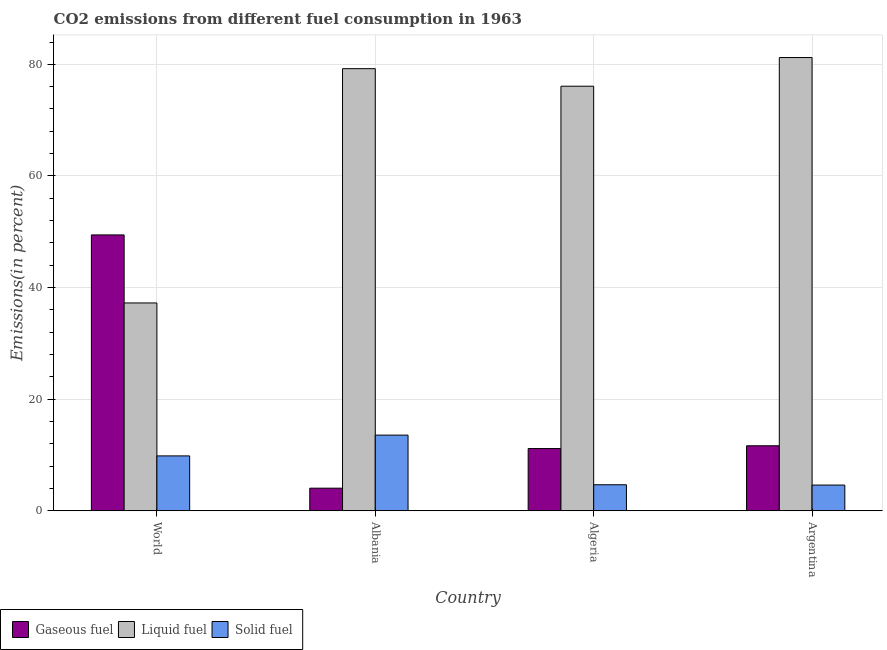How many different coloured bars are there?
Provide a succinct answer. 3. Are the number of bars on each tick of the X-axis equal?
Your response must be concise. Yes. How many bars are there on the 2nd tick from the left?
Offer a very short reply. 3. What is the label of the 2nd group of bars from the left?
Make the answer very short. Albania. In how many cases, is the number of bars for a given country not equal to the number of legend labels?
Your answer should be compact. 0. What is the percentage of liquid fuel emission in Algeria?
Give a very brief answer. 76.08. Across all countries, what is the maximum percentage of solid fuel emission?
Your answer should be compact. 13.56. Across all countries, what is the minimum percentage of liquid fuel emission?
Make the answer very short. 37.24. In which country was the percentage of solid fuel emission maximum?
Give a very brief answer. Albania. What is the total percentage of gaseous fuel emission in the graph?
Make the answer very short. 76.28. What is the difference between the percentage of liquid fuel emission in Algeria and that in World?
Your response must be concise. 38.84. What is the difference between the percentage of liquid fuel emission in Algeria and the percentage of solid fuel emission in World?
Your response must be concise. 66.25. What is the average percentage of solid fuel emission per country?
Offer a very short reply. 8.16. What is the difference between the percentage of liquid fuel emission and percentage of solid fuel emission in Algeria?
Your answer should be compact. 71.42. What is the ratio of the percentage of solid fuel emission in Albania to that in World?
Give a very brief answer. 1.38. Is the percentage of gaseous fuel emission in Albania less than that in World?
Ensure brevity in your answer.  Yes. Is the difference between the percentage of liquid fuel emission in Albania and Algeria greater than the difference between the percentage of gaseous fuel emission in Albania and Algeria?
Your answer should be compact. Yes. What is the difference between the highest and the second highest percentage of liquid fuel emission?
Give a very brief answer. 1.99. What is the difference between the highest and the lowest percentage of liquid fuel emission?
Your answer should be very brief. 43.98. Is the sum of the percentage of liquid fuel emission in Albania and Argentina greater than the maximum percentage of gaseous fuel emission across all countries?
Ensure brevity in your answer.  Yes. What does the 1st bar from the left in Algeria represents?
Provide a succinct answer. Gaseous fuel. What does the 3rd bar from the right in Algeria represents?
Ensure brevity in your answer.  Gaseous fuel. What is the difference between two consecutive major ticks on the Y-axis?
Offer a terse response. 20. Are the values on the major ticks of Y-axis written in scientific E-notation?
Ensure brevity in your answer.  No. Does the graph contain any zero values?
Give a very brief answer. No. Does the graph contain grids?
Offer a terse response. Yes. How are the legend labels stacked?
Provide a short and direct response. Horizontal. What is the title of the graph?
Make the answer very short. CO2 emissions from different fuel consumption in 1963. What is the label or title of the Y-axis?
Give a very brief answer. Emissions(in percent). What is the Emissions(in percent) in Gaseous fuel in World?
Provide a succinct answer. 49.43. What is the Emissions(in percent) in Liquid fuel in World?
Provide a short and direct response. 37.24. What is the Emissions(in percent) in Solid fuel in World?
Offer a very short reply. 9.83. What is the Emissions(in percent) in Gaseous fuel in Albania?
Offer a terse response. 4.05. What is the Emissions(in percent) of Liquid fuel in Albania?
Keep it short and to the point. 79.23. What is the Emissions(in percent) in Solid fuel in Albania?
Offer a terse response. 13.56. What is the Emissions(in percent) of Gaseous fuel in Algeria?
Ensure brevity in your answer.  11.15. What is the Emissions(in percent) of Liquid fuel in Algeria?
Offer a very short reply. 76.08. What is the Emissions(in percent) in Solid fuel in Algeria?
Your response must be concise. 4.66. What is the Emissions(in percent) of Gaseous fuel in Argentina?
Give a very brief answer. 11.65. What is the Emissions(in percent) of Liquid fuel in Argentina?
Keep it short and to the point. 81.22. What is the Emissions(in percent) in Solid fuel in Argentina?
Keep it short and to the point. 4.61. Across all countries, what is the maximum Emissions(in percent) of Gaseous fuel?
Keep it short and to the point. 49.43. Across all countries, what is the maximum Emissions(in percent) in Liquid fuel?
Offer a terse response. 81.22. Across all countries, what is the maximum Emissions(in percent) of Solid fuel?
Provide a short and direct response. 13.56. Across all countries, what is the minimum Emissions(in percent) of Gaseous fuel?
Your answer should be very brief. 4.05. Across all countries, what is the minimum Emissions(in percent) of Liquid fuel?
Keep it short and to the point. 37.24. Across all countries, what is the minimum Emissions(in percent) of Solid fuel?
Ensure brevity in your answer.  4.61. What is the total Emissions(in percent) of Gaseous fuel in the graph?
Ensure brevity in your answer.  76.28. What is the total Emissions(in percent) in Liquid fuel in the graph?
Your answer should be very brief. 273.77. What is the total Emissions(in percent) of Solid fuel in the graph?
Offer a very short reply. 32.66. What is the difference between the Emissions(in percent) of Gaseous fuel in World and that in Albania?
Provide a succinct answer. 45.38. What is the difference between the Emissions(in percent) of Liquid fuel in World and that in Albania?
Offer a terse response. -41.99. What is the difference between the Emissions(in percent) in Solid fuel in World and that in Albania?
Offer a very short reply. -3.72. What is the difference between the Emissions(in percent) of Gaseous fuel in World and that in Algeria?
Keep it short and to the point. 38.28. What is the difference between the Emissions(in percent) of Liquid fuel in World and that in Algeria?
Offer a very short reply. -38.84. What is the difference between the Emissions(in percent) of Solid fuel in World and that in Algeria?
Ensure brevity in your answer.  5.17. What is the difference between the Emissions(in percent) of Gaseous fuel in World and that in Argentina?
Provide a short and direct response. 37.78. What is the difference between the Emissions(in percent) of Liquid fuel in World and that in Argentina?
Provide a succinct answer. -43.98. What is the difference between the Emissions(in percent) of Solid fuel in World and that in Argentina?
Your answer should be very brief. 5.23. What is the difference between the Emissions(in percent) in Gaseous fuel in Albania and that in Algeria?
Your response must be concise. -7.1. What is the difference between the Emissions(in percent) in Liquid fuel in Albania and that in Algeria?
Your answer should be compact. 3.14. What is the difference between the Emissions(in percent) in Solid fuel in Albania and that in Algeria?
Offer a very short reply. 8.89. What is the difference between the Emissions(in percent) of Gaseous fuel in Albania and that in Argentina?
Offer a terse response. -7.6. What is the difference between the Emissions(in percent) in Liquid fuel in Albania and that in Argentina?
Make the answer very short. -1.99. What is the difference between the Emissions(in percent) in Solid fuel in Albania and that in Argentina?
Ensure brevity in your answer.  8.95. What is the difference between the Emissions(in percent) of Gaseous fuel in Algeria and that in Argentina?
Keep it short and to the point. -0.5. What is the difference between the Emissions(in percent) in Liquid fuel in Algeria and that in Argentina?
Keep it short and to the point. -5.14. What is the difference between the Emissions(in percent) of Solid fuel in Algeria and that in Argentina?
Ensure brevity in your answer.  0.06. What is the difference between the Emissions(in percent) in Gaseous fuel in World and the Emissions(in percent) in Liquid fuel in Albania?
Your response must be concise. -29.79. What is the difference between the Emissions(in percent) in Gaseous fuel in World and the Emissions(in percent) in Solid fuel in Albania?
Offer a very short reply. 35.88. What is the difference between the Emissions(in percent) of Liquid fuel in World and the Emissions(in percent) of Solid fuel in Albania?
Offer a very short reply. 23.68. What is the difference between the Emissions(in percent) of Gaseous fuel in World and the Emissions(in percent) of Liquid fuel in Algeria?
Provide a succinct answer. -26.65. What is the difference between the Emissions(in percent) of Gaseous fuel in World and the Emissions(in percent) of Solid fuel in Algeria?
Your response must be concise. 44.77. What is the difference between the Emissions(in percent) in Liquid fuel in World and the Emissions(in percent) in Solid fuel in Algeria?
Your answer should be very brief. 32.58. What is the difference between the Emissions(in percent) in Gaseous fuel in World and the Emissions(in percent) in Liquid fuel in Argentina?
Offer a very short reply. -31.79. What is the difference between the Emissions(in percent) of Gaseous fuel in World and the Emissions(in percent) of Solid fuel in Argentina?
Offer a very short reply. 44.83. What is the difference between the Emissions(in percent) of Liquid fuel in World and the Emissions(in percent) of Solid fuel in Argentina?
Offer a terse response. 32.63. What is the difference between the Emissions(in percent) of Gaseous fuel in Albania and the Emissions(in percent) of Liquid fuel in Algeria?
Offer a terse response. -72.03. What is the difference between the Emissions(in percent) in Gaseous fuel in Albania and the Emissions(in percent) in Solid fuel in Algeria?
Offer a very short reply. -0.61. What is the difference between the Emissions(in percent) in Liquid fuel in Albania and the Emissions(in percent) in Solid fuel in Algeria?
Your answer should be very brief. 74.56. What is the difference between the Emissions(in percent) in Gaseous fuel in Albania and the Emissions(in percent) in Liquid fuel in Argentina?
Give a very brief answer. -77.17. What is the difference between the Emissions(in percent) in Gaseous fuel in Albania and the Emissions(in percent) in Solid fuel in Argentina?
Make the answer very short. -0.56. What is the difference between the Emissions(in percent) in Liquid fuel in Albania and the Emissions(in percent) in Solid fuel in Argentina?
Give a very brief answer. 74.62. What is the difference between the Emissions(in percent) in Gaseous fuel in Algeria and the Emissions(in percent) in Liquid fuel in Argentina?
Make the answer very short. -70.07. What is the difference between the Emissions(in percent) of Gaseous fuel in Algeria and the Emissions(in percent) of Solid fuel in Argentina?
Your response must be concise. 6.54. What is the difference between the Emissions(in percent) in Liquid fuel in Algeria and the Emissions(in percent) in Solid fuel in Argentina?
Give a very brief answer. 71.48. What is the average Emissions(in percent) of Gaseous fuel per country?
Provide a short and direct response. 19.07. What is the average Emissions(in percent) in Liquid fuel per country?
Ensure brevity in your answer.  68.44. What is the average Emissions(in percent) in Solid fuel per country?
Provide a short and direct response. 8.16. What is the difference between the Emissions(in percent) of Gaseous fuel and Emissions(in percent) of Liquid fuel in World?
Offer a terse response. 12.19. What is the difference between the Emissions(in percent) in Gaseous fuel and Emissions(in percent) in Solid fuel in World?
Offer a terse response. 39.6. What is the difference between the Emissions(in percent) in Liquid fuel and Emissions(in percent) in Solid fuel in World?
Give a very brief answer. 27.41. What is the difference between the Emissions(in percent) of Gaseous fuel and Emissions(in percent) of Liquid fuel in Albania?
Keep it short and to the point. -75.18. What is the difference between the Emissions(in percent) of Gaseous fuel and Emissions(in percent) of Solid fuel in Albania?
Ensure brevity in your answer.  -9.51. What is the difference between the Emissions(in percent) in Liquid fuel and Emissions(in percent) in Solid fuel in Albania?
Ensure brevity in your answer.  65.67. What is the difference between the Emissions(in percent) of Gaseous fuel and Emissions(in percent) of Liquid fuel in Algeria?
Provide a succinct answer. -64.93. What is the difference between the Emissions(in percent) in Gaseous fuel and Emissions(in percent) in Solid fuel in Algeria?
Provide a succinct answer. 6.49. What is the difference between the Emissions(in percent) in Liquid fuel and Emissions(in percent) in Solid fuel in Algeria?
Make the answer very short. 71.42. What is the difference between the Emissions(in percent) in Gaseous fuel and Emissions(in percent) in Liquid fuel in Argentina?
Your answer should be very brief. -69.57. What is the difference between the Emissions(in percent) of Gaseous fuel and Emissions(in percent) of Solid fuel in Argentina?
Give a very brief answer. 7.04. What is the difference between the Emissions(in percent) in Liquid fuel and Emissions(in percent) in Solid fuel in Argentina?
Your response must be concise. 76.61. What is the ratio of the Emissions(in percent) in Gaseous fuel in World to that in Albania?
Your response must be concise. 12.21. What is the ratio of the Emissions(in percent) in Liquid fuel in World to that in Albania?
Your answer should be compact. 0.47. What is the ratio of the Emissions(in percent) of Solid fuel in World to that in Albania?
Keep it short and to the point. 0.73. What is the ratio of the Emissions(in percent) of Gaseous fuel in World to that in Algeria?
Your response must be concise. 4.43. What is the ratio of the Emissions(in percent) in Liquid fuel in World to that in Algeria?
Your answer should be very brief. 0.49. What is the ratio of the Emissions(in percent) in Solid fuel in World to that in Algeria?
Make the answer very short. 2.11. What is the ratio of the Emissions(in percent) in Gaseous fuel in World to that in Argentina?
Give a very brief answer. 4.24. What is the ratio of the Emissions(in percent) of Liquid fuel in World to that in Argentina?
Make the answer very short. 0.46. What is the ratio of the Emissions(in percent) of Solid fuel in World to that in Argentina?
Give a very brief answer. 2.14. What is the ratio of the Emissions(in percent) in Gaseous fuel in Albania to that in Algeria?
Keep it short and to the point. 0.36. What is the ratio of the Emissions(in percent) in Liquid fuel in Albania to that in Algeria?
Provide a short and direct response. 1.04. What is the ratio of the Emissions(in percent) of Solid fuel in Albania to that in Algeria?
Ensure brevity in your answer.  2.91. What is the ratio of the Emissions(in percent) in Gaseous fuel in Albania to that in Argentina?
Provide a succinct answer. 0.35. What is the ratio of the Emissions(in percent) in Liquid fuel in Albania to that in Argentina?
Make the answer very short. 0.98. What is the ratio of the Emissions(in percent) of Solid fuel in Albania to that in Argentina?
Offer a terse response. 2.94. What is the ratio of the Emissions(in percent) in Gaseous fuel in Algeria to that in Argentina?
Provide a short and direct response. 0.96. What is the ratio of the Emissions(in percent) of Liquid fuel in Algeria to that in Argentina?
Your answer should be compact. 0.94. What is the ratio of the Emissions(in percent) of Solid fuel in Algeria to that in Argentina?
Offer a very short reply. 1.01. What is the difference between the highest and the second highest Emissions(in percent) of Gaseous fuel?
Ensure brevity in your answer.  37.78. What is the difference between the highest and the second highest Emissions(in percent) in Liquid fuel?
Offer a terse response. 1.99. What is the difference between the highest and the second highest Emissions(in percent) of Solid fuel?
Provide a succinct answer. 3.72. What is the difference between the highest and the lowest Emissions(in percent) of Gaseous fuel?
Keep it short and to the point. 45.38. What is the difference between the highest and the lowest Emissions(in percent) in Liquid fuel?
Give a very brief answer. 43.98. What is the difference between the highest and the lowest Emissions(in percent) of Solid fuel?
Keep it short and to the point. 8.95. 